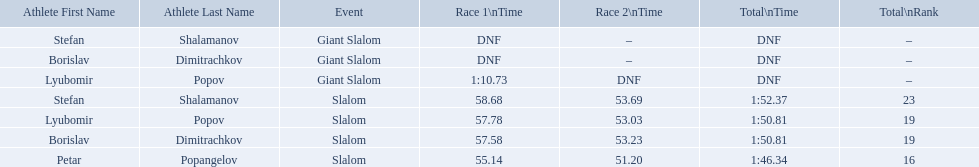What were the event names during bulgaria at the 1988 winter olympics? Stefan Shalamanov, Borislav Dimitrachkov, Lyubomir Popov. And which players participated at giant slalom? Giant Slalom, Giant Slalom, Giant Slalom, Slalom, Slalom, Slalom, Slalom. What were their race 1 times? DNF, DNF, 1:10.73. What was lyubomir popov's personal time? 1:10.73. What are all the competitions lyubomir popov competed in? Lyubomir Popov, Lyubomir Popov. Of those, which were giant slalom races? Giant Slalom. What was his time in race 1? 1:10.73. Which event is the giant slalom? Giant Slalom, Giant Slalom, Giant Slalom. Which one is lyubomir popov? Lyubomir Popov. What is race 1 tim? 1:10.73. 